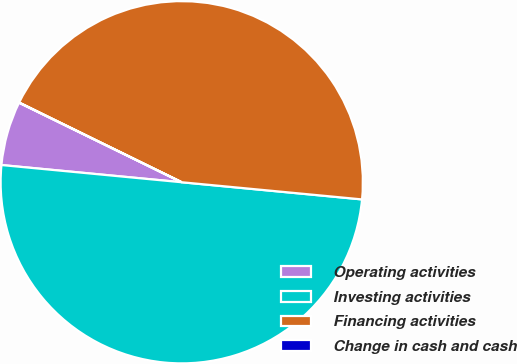Convert chart to OTSL. <chart><loc_0><loc_0><loc_500><loc_500><pie_chart><fcel>Operating activities<fcel>Investing activities<fcel>Financing activities<fcel>Change in cash and cash<nl><fcel>5.72%<fcel>50.0%<fcel>44.25%<fcel>0.02%<nl></chart> 